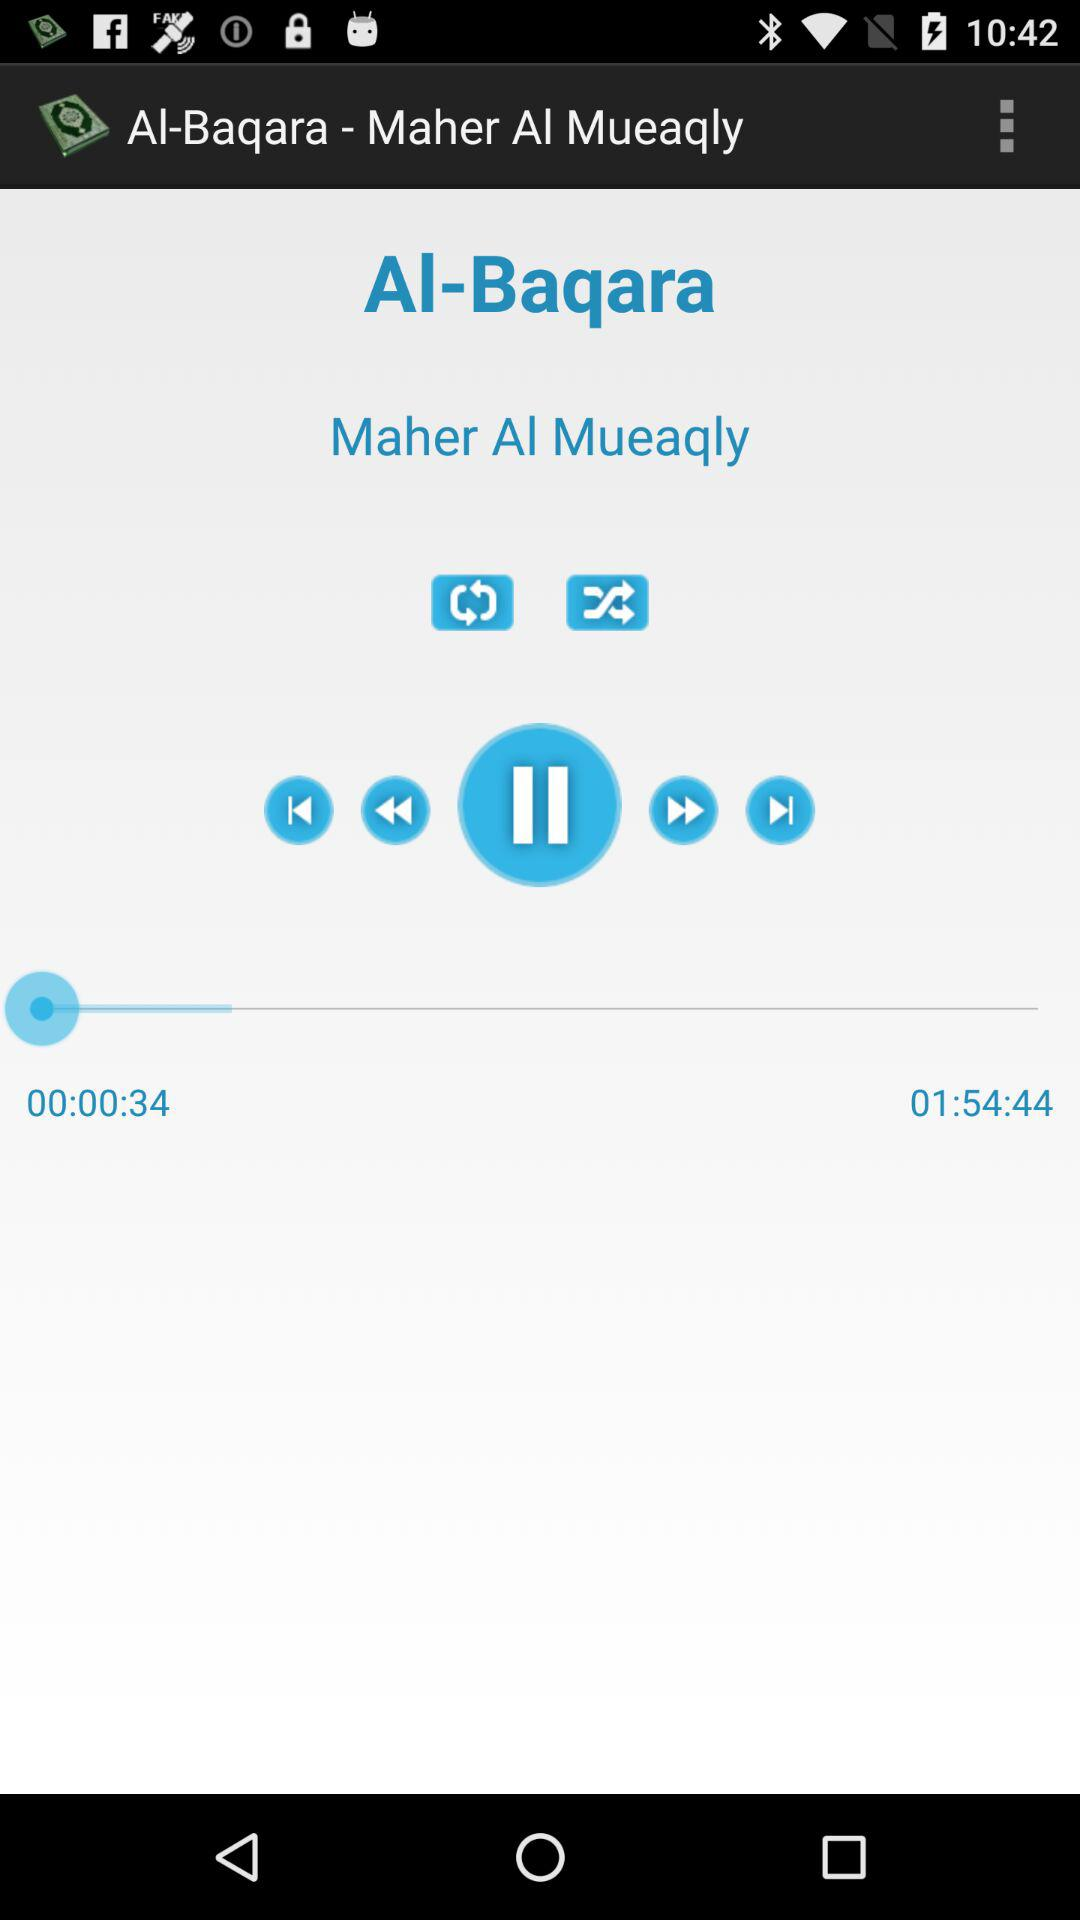How long has the song been playing? The song has been playing for 34 seconds. 